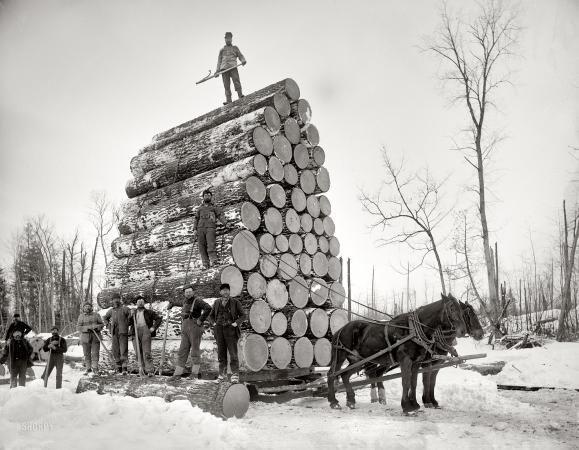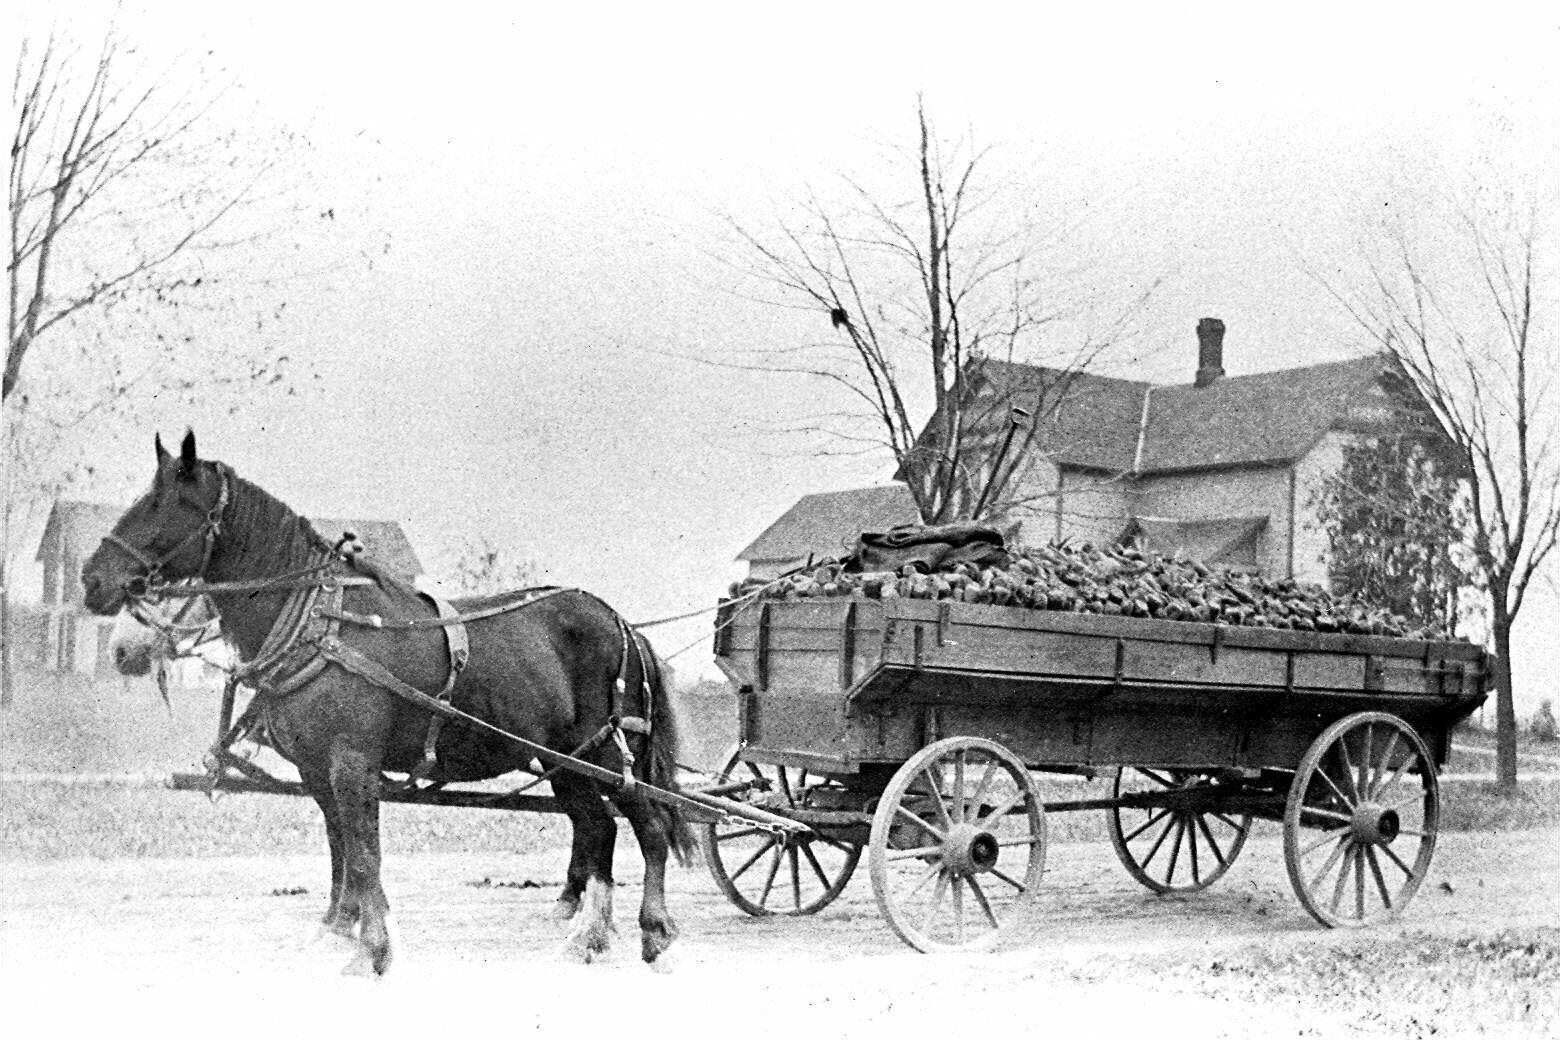The first image is the image on the left, the second image is the image on the right. Considering the images on both sides, is "One of the carriages is carrying an oversized load." valid? Answer yes or no. Yes. The first image is the image on the left, the second image is the image on the right. Analyze the images presented: Is the assertion "In one image, two people are sitting in a carriage with only two large wheels, which is pulled by one horse." valid? Answer yes or no. No. 